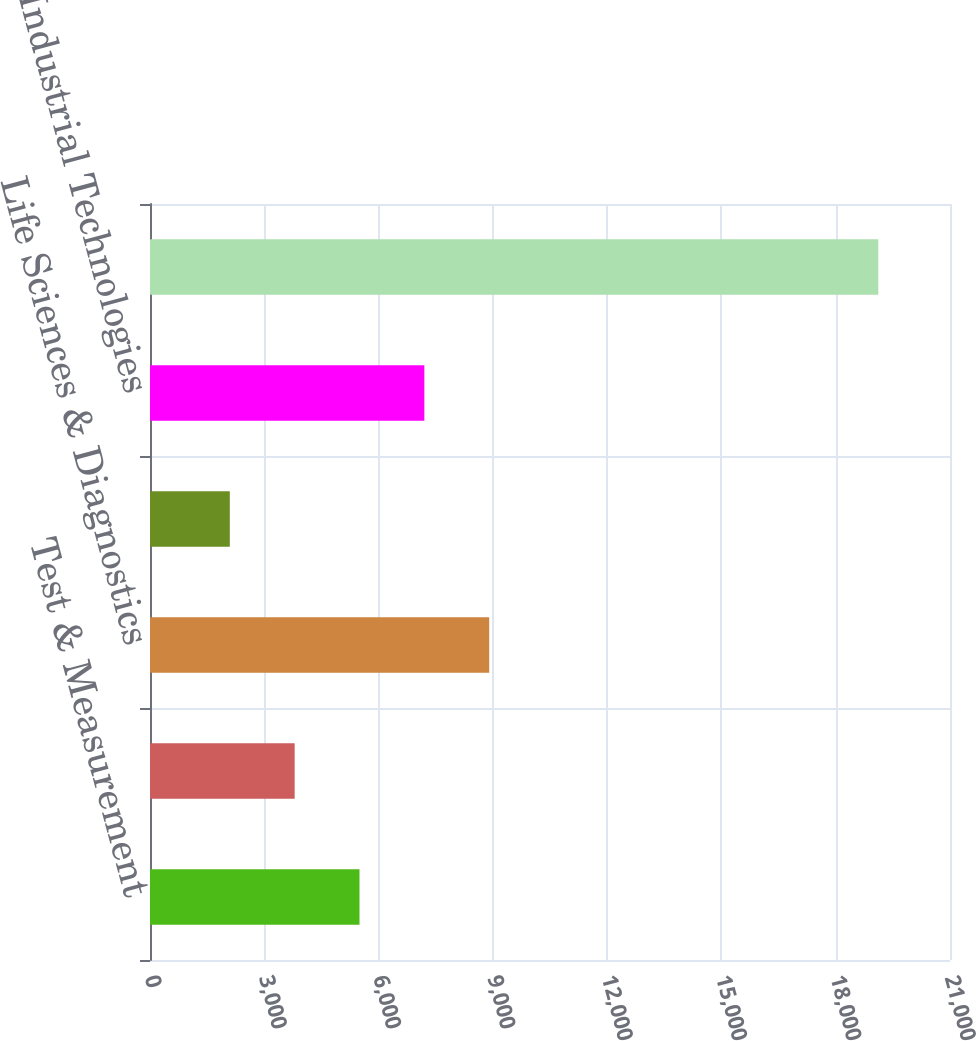Convert chart. <chart><loc_0><loc_0><loc_500><loc_500><bar_chart><fcel>Test & Measurement<fcel>Environmental<fcel>Life Sciences & Diagnostics<fcel>Dental<fcel>Industrial Technologies<fcel>Total<nl><fcel>5499.52<fcel>3797.21<fcel>8904.14<fcel>2094.9<fcel>7201.83<fcel>19118<nl></chart> 